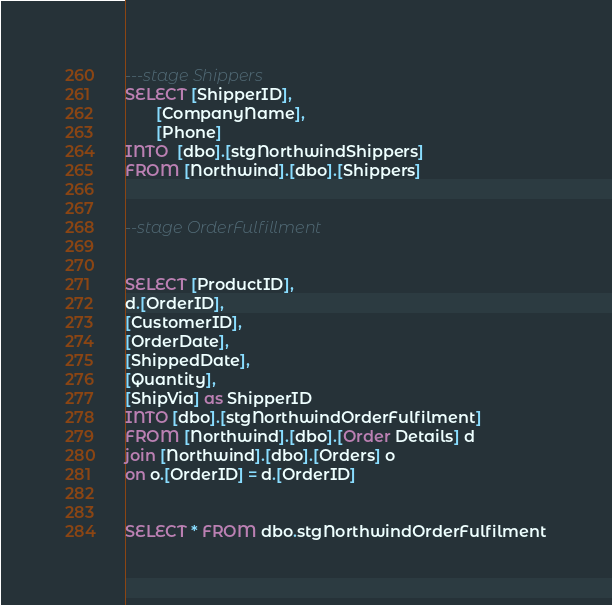<code> <loc_0><loc_0><loc_500><loc_500><_SQL_>---stage Shippers       
SELECT [ShipperID],
       [CompanyName],
	   [Phone]
INTO  [dbo].[stgNorthwindShippers]
FROM [Northwind].[dbo].[Shippers]


--stage OrderFulfillment


SELECT [ProductID],
d.[OrderID],
[CustomerID],
[OrderDate],
[ShippedDate],
[Quantity],
[ShipVia] as ShipperID
INTO [dbo].[stgNorthwindOrderFulfilment]
FROM [Northwind].[dbo].[Order Details] d
join [Northwind].[dbo].[Orders] o
on o.[OrderID] = d.[OrderID] 


SELECT * FROM dbo.stgNorthwindOrderFulfilment</code> 